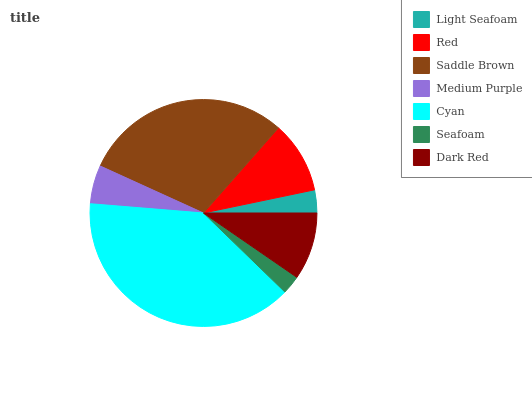Is Seafoam the minimum?
Answer yes or no. Yes. Is Cyan the maximum?
Answer yes or no. Yes. Is Red the minimum?
Answer yes or no. No. Is Red the maximum?
Answer yes or no. No. Is Red greater than Light Seafoam?
Answer yes or no. Yes. Is Light Seafoam less than Red?
Answer yes or no. Yes. Is Light Seafoam greater than Red?
Answer yes or no. No. Is Red less than Light Seafoam?
Answer yes or no. No. Is Dark Red the high median?
Answer yes or no. Yes. Is Dark Red the low median?
Answer yes or no. Yes. Is Saddle Brown the high median?
Answer yes or no. No. Is Seafoam the low median?
Answer yes or no. No. 